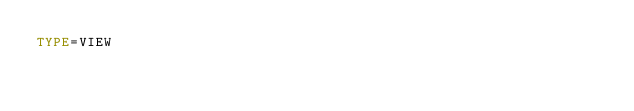<code> <loc_0><loc_0><loc_500><loc_500><_VisualBasic_>TYPE=VIEW</code> 